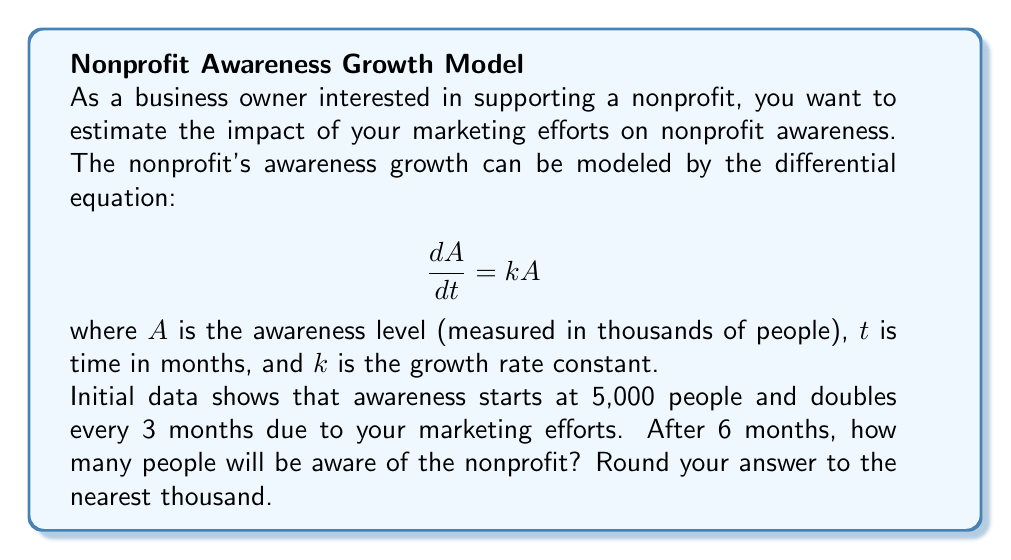Give your solution to this math problem. Let's solve this step-by-step:

1) First, we need to find the value of $k$. We know that awareness doubles every 3 months, so:

   $A(3) = 2A(0)$
   $A(0)e^{3k} = 2A(0)$
   $e^{3k} = 2$

2) Taking the natural log of both sides:

   $3k = \ln(2)$
   $k = \frac{\ln(2)}{3} \approx 0.231$

3) Now we have our complete differential equation:

   $$\frac{dA}{dt} = 0.231A$$

4) The general solution to this equation is:

   $A(t) = Ce^{0.231t}$

5) Using the initial condition $A(0) = 5$ (remember, $A$ is in thousands):

   $5 = Ce^{0.231(0)}$
   $C = 5$

6) So our specific solution is:

   $A(t) = 5e^{0.231t}$

7) To find awareness after 6 months, we calculate $A(6)$:

   $A(6) = 5e^{0.231(6)} \approx 20.085$

8) Rounding to the nearest thousand:

   $A(6) \approx 20,000$ people
Answer: 20,000 people 